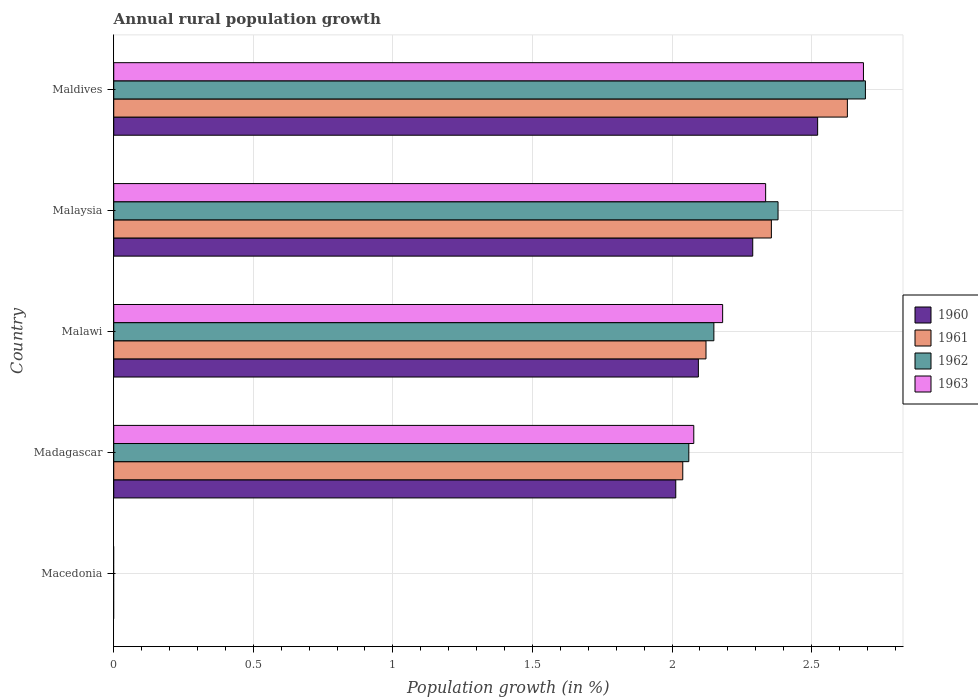How many different coloured bars are there?
Your response must be concise. 4. How many bars are there on the 1st tick from the top?
Keep it short and to the point. 4. What is the label of the 5th group of bars from the top?
Make the answer very short. Macedonia. In how many cases, is the number of bars for a given country not equal to the number of legend labels?
Provide a short and direct response. 1. Across all countries, what is the maximum percentage of rural population growth in 1962?
Keep it short and to the point. 2.69. Across all countries, what is the minimum percentage of rural population growth in 1962?
Your answer should be compact. 0. In which country was the percentage of rural population growth in 1960 maximum?
Ensure brevity in your answer.  Maldives. What is the total percentage of rural population growth in 1963 in the graph?
Provide a short and direct response. 9.28. What is the difference between the percentage of rural population growth in 1961 in Malawi and that in Maldives?
Your answer should be very brief. -0.51. What is the difference between the percentage of rural population growth in 1961 in Malaysia and the percentage of rural population growth in 1962 in Maldives?
Give a very brief answer. -0.34. What is the average percentage of rural population growth in 1960 per country?
Your answer should be compact. 1.78. What is the difference between the percentage of rural population growth in 1963 and percentage of rural population growth in 1961 in Malawi?
Provide a short and direct response. 0.06. In how many countries, is the percentage of rural population growth in 1960 greater than 2.2 %?
Provide a short and direct response. 2. What is the ratio of the percentage of rural population growth in 1960 in Malawi to that in Malaysia?
Your answer should be compact. 0.91. Is the percentage of rural population growth in 1962 in Madagascar less than that in Maldives?
Your answer should be compact. Yes. Is the difference between the percentage of rural population growth in 1963 in Madagascar and Maldives greater than the difference between the percentage of rural population growth in 1961 in Madagascar and Maldives?
Provide a short and direct response. No. What is the difference between the highest and the second highest percentage of rural population growth in 1963?
Ensure brevity in your answer.  0.35. What is the difference between the highest and the lowest percentage of rural population growth in 1963?
Ensure brevity in your answer.  2.69. Is it the case that in every country, the sum of the percentage of rural population growth in 1962 and percentage of rural population growth in 1961 is greater than the sum of percentage of rural population growth in 1963 and percentage of rural population growth in 1960?
Ensure brevity in your answer.  No. How many bars are there?
Offer a very short reply. 16. Are all the bars in the graph horizontal?
Give a very brief answer. Yes. How many countries are there in the graph?
Offer a very short reply. 5. What is the difference between two consecutive major ticks on the X-axis?
Your answer should be very brief. 0.5. Are the values on the major ticks of X-axis written in scientific E-notation?
Give a very brief answer. No. Does the graph contain any zero values?
Make the answer very short. Yes. Does the graph contain grids?
Ensure brevity in your answer.  Yes. How many legend labels are there?
Your answer should be compact. 4. How are the legend labels stacked?
Offer a very short reply. Vertical. What is the title of the graph?
Make the answer very short. Annual rural population growth. Does "1978" appear as one of the legend labels in the graph?
Provide a short and direct response. No. What is the label or title of the X-axis?
Keep it short and to the point. Population growth (in %). What is the Population growth (in %) of 1962 in Macedonia?
Your answer should be very brief. 0. What is the Population growth (in %) in 1960 in Madagascar?
Provide a short and direct response. 2.01. What is the Population growth (in %) of 1961 in Madagascar?
Provide a succinct answer. 2.04. What is the Population growth (in %) in 1962 in Madagascar?
Provide a short and direct response. 2.06. What is the Population growth (in %) of 1963 in Madagascar?
Your answer should be very brief. 2.08. What is the Population growth (in %) of 1960 in Malawi?
Give a very brief answer. 2.09. What is the Population growth (in %) of 1961 in Malawi?
Offer a terse response. 2.12. What is the Population growth (in %) in 1962 in Malawi?
Your response must be concise. 2.15. What is the Population growth (in %) of 1963 in Malawi?
Your answer should be compact. 2.18. What is the Population growth (in %) in 1960 in Malaysia?
Provide a short and direct response. 2.29. What is the Population growth (in %) of 1961 in Malaysia?
Your response must be concise. 2.36. What is the Population growth (in %) in 1962 in Malaysia?
Your answer should be very brief. 2.38. What is the Population growth (in %) in 1963 in Malaysia?
Provide a short and direct response. 2.34. What is the Population growth (in %) in 1960 in Maldives?
Provide a succinct answer. 2.52. What is the Population growth (in %) of 1961 in Maldives?
Your answer should be compact. 2.63. What is the Population growth (in %) of 1962 in Maldives?
Offer a terse response. 2.69. What is the Population growth (in %) of 1963 in Maldives?
Give a very brief answer. 2.69. Across all countries, what is the maximum Population growth (in %) in 1960?
Give a very brief answer. 2.52. Across all countries, what is the maximum Population growth (in %) of 1961?
Your response must be concise. 2.63. Across all countries, what is the maximum Population growth (in %) of 1962?
Provide a succinct answer. 2.69. Across all countries, what is the maximum Population growth (in %) of 1963?
Offer a terse response. 2.69. Across all countries, what is the minimum Population growth (in %) of 1963?
Offer a very short reply. 0. What is the total Population growth (in %) in 1960 in the graph?
Make the answer very short. 8.92. What is the total Population growth (in %) of 1961 in the graph?
Give a very brief answer. 9.14. What is the total Population growth (in %) in 1962 in the graph?
Give a very brief answer. 9.28. What is the total Population growth (in %) in 1963 in the graph?
Ensure brevity in your answer.  9.28. What is the difference between the Population growth (in %) in 1960 in Madagascar and that in Malawi?
Give a very brief answer. -0.08. What is the difference between the Population growth (in %) of 1961 in Madagascar and that in Malawi?
Ensure brevity in your answer.  -0.08. What is the difference between the Population growth (in %) in 1962 in Madagascar and that in Malawi?
Ensure brevity in your answer.  -0.09. What is the difference between the Population growth (in %) of 1963 in Madagascar and that in Malawi?
Keep it short and to the point. -0.1. What is the difference between the Population growth (in %) of 1960 in Madagascar and that in Malaysia?
Your answer should be very brief. -0.28. What is the difference between the Population growth (in %) of 1961 in Madagascar and that in Malaysia?
Provide a short and direct response. -0.32. What is the difference between the Population growth (in %) in 1962 in Madagascar and that in Malaysia?
Your answer should be compact. -0.32. What is the difference between the Population growth (in %) of 1963 in Madagascar and that in Malaysia?
Provide a succinct answer. -0.26. What is the difference between the Population growth (in %) in 1960 in Madagascar and that in Maldives?
Make the answer very short. -0.51. What is the difference between the Population growth (in %) of 1961 in Madagascar and that in Maldives?
Your response must be concise. -0.59. What is the difference between the Population growth (in %) in 1962 in Madagascar and that in Maldives?
Offer a terse response. -0.63. What is the difference between the Population growth (in %) in 1963 in Madagascar and that in Maldives?
Offer a very short reply. -0.61. What is the difference between the Population growth (in %) of 1960 in Malawi and that in Malaysia?
Your answer should be compact. -0.19. What is the difference between the Population growth (in %) of 1961 in Malawi and that in Malaysia?
Offer a very short reply. -0.23. What is the difference between the Population growth (in %) of 1962 in Malawi and that in Malaysia?
Your answer should be very brief. -0.23. What is the difference between the Population growth (in %) of 1963 in Malawi and that in Malaysia?
Provide a succinct answer. -0.15. What is the difference between the Population growth (in %) in 1960 in Malawi and that in Maldives?
Your answer should be very brief. -0.43. What is the difference between the Population growth (in %) in 1961 in Malawi and that in Maldives?
Offer a very short reply. -0.51. What is the difference between the Population growth (in %) in 1962 in Malawi and that in Maldives?
Ensure brevity in your answer.  -0.54. What is the difference between the Population growth (in %) in 1963 in Malawi and that in Maldives?
Provide a short and direct response. -0.5. What is the difference between the Population growth (in %) of 1960 in Malaysia and that in Maldives?
Ensure brevity in your answer.  -0.23. What is the difference between the Population growth (in %) of 1961 in Malaysia and that in Maldives?
Give a very brief answer. -0.27. What is the difference between the Population growth (in %) in 1962 in Malaysia and that in Maldives?
Provide a short and direct response. -0.31. What is the difference between the Population growth (in %) of 1963 in Malaysia and that in Maldives?
Offer a terse response. -0.35. What is the difference between the Population growth (in %) in 1960 in Madagascar and the Population growth (in %) in 1961 in Malawi?
Your answer should be compact. -0.11. What is the difference between the Population growth (in %) in 1960 in Madagascar and the Population growth (in %) in 1962 in Malawi?
Offer a terse response. -0.14. What is the difference between the Population growth (in %) in 1960 in Madagascar and the Population growth (in %) in 1963 in Malawi?
Provide a short and direct response. -0.17. What is the difference between the Population growth (in %) of 1961 in Madagascar and the Population growth (in %) of 1962 in Malawi?
Keep it short and to the point. -0.11. What is the difference between the Population growth (in %) in 1961 in Madagascar and the Population growth (in %) in 1963 in Malawi?
Ensure brevity in your answer.  -0.14. What is the difference between the Population growth (in %) in 1962 in Madagascar and the Population growth (in %) in 1963 in Malawi?
Make the answer very short. -0.12. What is the difference between the Population growth (in %) in 1960 in Madagascar and the Population growth (in %) in 1961 in Malaysia?
Offer a terse response. -0.34. What is the difference between the Population growth (in %) in 1960 in Madagascar and the Population growth (in %) in 1962 in Malaysia?
Offer a terse response. -0.37. What is the difference between the Population growth (in %) in 1960 in Madagascar and the Population growth (in %) in 1963 in Malaysia?
Offer a terse response. -0.32. What is the difference between the Population growth (in %) of 1961 in Madagascar and the Population growth (in %) of 1962 in Malaysia?
Provide a succinct answer. -0.34. What is the difference between the Population growth (in %) in 1961 in Madagascar and the Population growth (in %) in 1963 in Malaysia?
Provide a succinct answer. -0.3. What is the difference between the Population growth (in %) in 1962 in Madagascar and the Population growth (in %) in 1963 in Malaysia?
Give a very brief answer. -0.28. What is the difference between the Population growth (in %) in 1960 in Madagascar and the Population growth (in %) in 1961 in Maldives?
Provide a short and direct response. -0.61. What is the difference between the Population growth (in %) of 1960 in Madagascar and the Population growth (in %) of 1962 in Maldives?
Offer a very short reply. -0.68. What is the difference between the Population growth (in %) of 1960 in Madagascar and the Population growth (in %) of 1963 in Maldives?
Offer a terse response. -0.67. What is the difference between the Population growth (in %) in 1961 in Madagascar and the Population growth (in %) in 1962 in Maldives?
Provide a short and direct response. -0.65. What is the difference between the Population growth (in %) in 1961 in Madagascar and the Population growth (in %) in 1963 in Maldives?
Give a very brief answer. -0.65. What is the difference between the Population growth (in %) in 1962 in Madagascar and the Population growth (in %) in 1963 in Maldives?
Provide a short and direct response. -0.63. What is the difference between the Population growth (in %) in 1960 in Malawi and the Population growth (in %) in 1961 in Malaysia?
Your response must be concise. -0.26. What is the difference between the Population growth (in %) in 1960 in Malawi and the Population growth (in %) in 1962 in Malaysia?
Provide a succinct answer. -0.29. What is the difference between the Population growth (in %) in 1960 in Malawi and the Population growth (in %) in 1963 in Malaysia?
Your answer should be very brief. -0.24. What is the difference between the Population growth (in %) of 1961 in Malawi and the Population growth (in %) of 1962 in Malaysia?
Ensure brevity in your answer.  -0.26. What is the difference between the Population growth (in %) in 1961 in Malawi and the Population growth (in %) in 1963 in Malaysia?
Your response must be concise. -0.21. What is the difference between the Population growth (in %) of 1962 in Malawi and the Population growth (in %) of 1963 in Malaysia?
Offer a very short reply. -0.19. What is the difference between the Population growth (in %) of 1960 in Malawi and the Population growth (in %) of 1961 in Maldives?
Make the answer very short. -0.53. What is the difference between the Population growth (in %) in 1960 in Malawi and the Population growth (in %) in 1962 in Maldives?
Your response must be concise. -0.6. What is the difference between the Population growth (in %) of 1960 in Malawi and the Population growth (in %) of 1963 in Maldives?
Give a very brief answer. -0.59. What is the difference between the Population growth (in %) in 1961 in Malawi and the Population growth (in %) in 1962 in Maldives?
Give a very brief answer. -0.57. What is the difference between the Population growth (in %) in 1961 in Malawi and the Population growth (in %) in 1963 in Maldives?
Keep it short and to the point. -0.56. What is the difference between the Population growth (in %) of 1962 in Malawi and the Population growth (in %) of 1963 in Maldives?
Your answer should be compact. -0.54. What is the difference between the Population growth (in %) of 1960 in Malaysia and the Population growth (in %) of 1961 in Maldives?
Ensure brevity in your answer.  -0.34. What is the difference between the Population growth (in %) in 1960 in Malaysia and the Population growth (in %) in 1962 in Maldives?
Keep it short and to the point. -0.4. What is the difference between the Population growth (in %) of 1960 in Malaysia and the Population growth (in %) of 1963 in Maldives?
Give a very brief answer. -0.4. What is the difference between the Population growth (in %) in 1961 in Malaysia and the Population growth (in %) in 1962 in Maldives?
Provide a short and direct response. -0.34. What is the difference between the Population growth (in %) in 1961 in Malaysia and the Population growth (in %) in 1963 in Maldives?
Offer a very short reply. -0.33. What is the difference between the Population growth (in %) of 1962 in Malaysia and the Population growth (in %) of 1963 in Maldives?
Keep it short and to the point. -0.31. What is the average Population growth (in %) of 1960 per country?
Your response must be concise. 1.78. What is the average Population growth (in %) of 1961 per country?
Provide a short and direct response. 1.83. What is the average Population growth (in %) in 1962 per country?
Give a very brief answer. 1.86. What is the average Population growth (in %) in 1963 per country?
Your response must be concise. 1.86. What is the difference between the Population growth (in %) of 1960 and Population growth (in %) of 1961 in Madagascar?
Your answer should be very brief. -0.03. What is the difference between the Population growth (in %) in 1960 and Population growth (in %) in 1962 in Madagascar?
Ensure brevity in your answer.  -0.05. What is the difference between the Population growth (in %) of 1960 and Population growth (in %) of 1963 in Madagascar?
Keep it short and to the point. -0.06. What is the difference between the Population growth (in %) of 1961 and Population growth (in %) of 1962 in Madagascar?
Keep it short and to the point. -0.02. What is the difference between the Population growth (in %) of 1961 and Population growth (in %) of 1963 in Madagascar?
Offer a very short reply. -0.04. What is the difference between the Population growth (in %) in 1962 and Population growth (in %) in 1963 in Madagascar?
Your answer should be compact. -0.02. What is the difference between the Population growth (in %) in 1960 and Population growth (in %) in 1961 in Malawi?
Your response must be concise. -0.03. What is the difference between the Population growth (in %) of 1960 and Population growth (in %) of 1962 in Malawi?
Offer a very short reply. -0.06. What is the difference between the Population growth (in %) of 1960 and Population growth (in %) of 1963 in Malawi?
Offer a very short reply. -0.09. What is the difference between the Population growth (in %) of 1961 and Population growth (in %) of 1962 in Malawi?
Offer a very short reply. -0.03. What is the difference between the Population growth (in %) of 1961 and Population growth (in %) of 1963 in Malawi?
Give a very brief answer. -0.06. What is the difference between the Population growth (in %) in 1962 and Population growth (in %) in 1963 in Malawi?
Offer a terse response. -0.03. What is the difference between the Population growth (in %) in 1960 and Population growth (in %) in 1961 in Malaysia?
Provide a short and direct response. -0.07. What is the difference between the Population growth (in %) of 1960 and Population growth (in %) of 1962 in Malaysia?
Make the answer very short. -0.09. What is the difference between the Population growth (in %) in 1960 and Population growth (in %) in 1963 in Malaysia?
Provide a succinct answer. -0.05. What is the difference between the Population growth (in %) in 1961 and Population growth (in %) in 1962 in Malaysia?
Offer a terse response. -0.02. What is the difference between the Population growth (in %) of 1961 and Population growth (in %) of 1963 in Malaysia?
Your answer should be very brief. 0.02. What is the difference between the Population growth (in %) in 1962 and Population growth (in %) in 1963 in Malaysia?
Ensure brevity in your answer.  0.04. What is the difference between the Population growth (in %) in 1960 and Population growth (in %) in 1961 in Maldives?
Give a very brief answer. -0.11. What is the difference between the Population growth (in %) of 1960 and Population growth (in %) of 1962 in Maldives?
Your answer should be compact. -0.17. What is the difference between the Population growth (in %) of 1960 and Population growth (in %) of 1963 in Maldives?
Your answer should be very brief. -0.16. What is the difference between the Population growth (in %) of 1961 and Population growth (in %) of 1962 in Maldives?
Give a very brief answer. -0.06. What is the difference between the Population growth (in %) in 1961 and Population growth (in %) in 1963 in Maldives?
Give a very brief answer. -0.06. What is the difference between the Population growth (in %) of 1962 and Population growth (in %) of 1963 in Maldives?
Give a very brief answer. 0.01. What is the ratio of the Population growth (in %) of 1960 in Madagascar to that in Malawi?
Provide a succinct answer. 0.96. What is the ratio of the Population growth (in %) in 1961 in Madagascar to that in Malawi?
Offer a terse response. 0.96. What is the ratio of the Population growth (in %) in 1962 in Madagascar to that in Malawi?
Give a very brief answer. 0.96. What is the ratio of the Population growth (in %) in 1963 in Madagascar to that in Malawi?
Make the answer very short. 0.95. What is the ratio of the Population growth (in %) in 1960 in Madagascar to that in Malaysia?
Offer a terse response. 0.88. What is the ratio of the Population growth (in %) of 1961 in Madagascar to that in Malaysia?
Make the answer very short. 0.87. What is the ratio of the Population growth (in %) of 1962 in Madagascar to that in Malaysia?
Provide a succinct answer. 0.87. What is the ratio of the Population growth (in %) of 1963 in Madagascar to that in Malaysia?
Make the answer very short. 0.89. What is the ratio of the Population growth (in %) of 1960 in Madagascar to that in Maldives?
Your response must be concise. 0.8. What is the ratio of the Population growth (in %) of 1961 in Madagascar to that in Maldives?
Make the answer very short. 0.78. What is the ratio of the Population growth (in %) of 1962 in Madagascar to that in Maldives?
Your answer should be compact. 0.77. What is the ratio of the Population growth (in %) of 1963 in Madagascar to that in Maldives?
Keep it short and to the point. 0.77. What is the ratio of the Population growth (in %) of 1960 in Malawi to that in Malaysia?
Your response must be concise. 0.91. What is the ratio of the Population growth (in %) of 1961 in Malawi to that in Malaysia?
Offer a terse response. 0.9. What is the ratio of the Population growth (in %) in 1962 in Malawi to that in Malaysia?
Provide a succinct answer. 0.9. What is the ratio of the Population growth (in %) in 1963 in Malawi to that in Malaysia?
Offer a very short reply. 0.93. What is the ratio of the Population growth (in %) of 1960 in Malawi to that in Maldives?
Make the answer very short. 0.83. What is the ratio of the Population growth (in %) in 1961 in Malawi to that in Maldives?
Offer a very short reply. 0.81. What is the ratio of the Population growth (in %) of 1962 in Malawi to that in Maldives?
Ensure brevity in your answer.  0.8. What is the ratio of the Population growth (in %) of 1963 in Malawi to that in Maldives?
Give a very brief answer. 0.81. What is the ratio of the Population growth (in %) in 1960 in Malaysia to that in Maldives?
Ensure brevity in your answer.  0.91. What is the ratio of the Population growth (in %) in 1961 in Malaysia to that in Maldives?
Give a very brief answer. 0.9. What is the ratio of the Population growth (in %) in 1962 in Malaysia to that in Maldives?
Ensure brevity in your answer.  0.88. What is the ratio of the Population growth (in %) of 1963 in Malaysia to that in Maldives?
Provide a succinct answer. 0.87. What is the difference between the highest and the second highest Population growth (in %) in 1960?
Make the answer very short. 0.23. What is the difference between the highest and the second highest Population growth (in %) in 1961?
Ensure brevity in your answer.  0.27. What is the difference between the highest and the second highest Population growth (in %) in 1962?
Make the answer very short. 0.31. What is the difference between the highest and the second highest Population growth (in %) of 1963?
Offer a terse response. 0.35. What is the difference between the highest and the lowest Population growth (in %) in 1960?
Your answer should be very brief. 2.52. What is the difference between the highest and the lowest Population growth (in %) of 1961?
Offer a very short reply. 2.63. What is the difference between the highest and the lowest Population growth (in %) of 1962?
Ensure brevity in your answer.  2.69. What is the difference between the highest and the lowest Population growth (in %) in 1963?
Offer a very short reply. 2.69. 